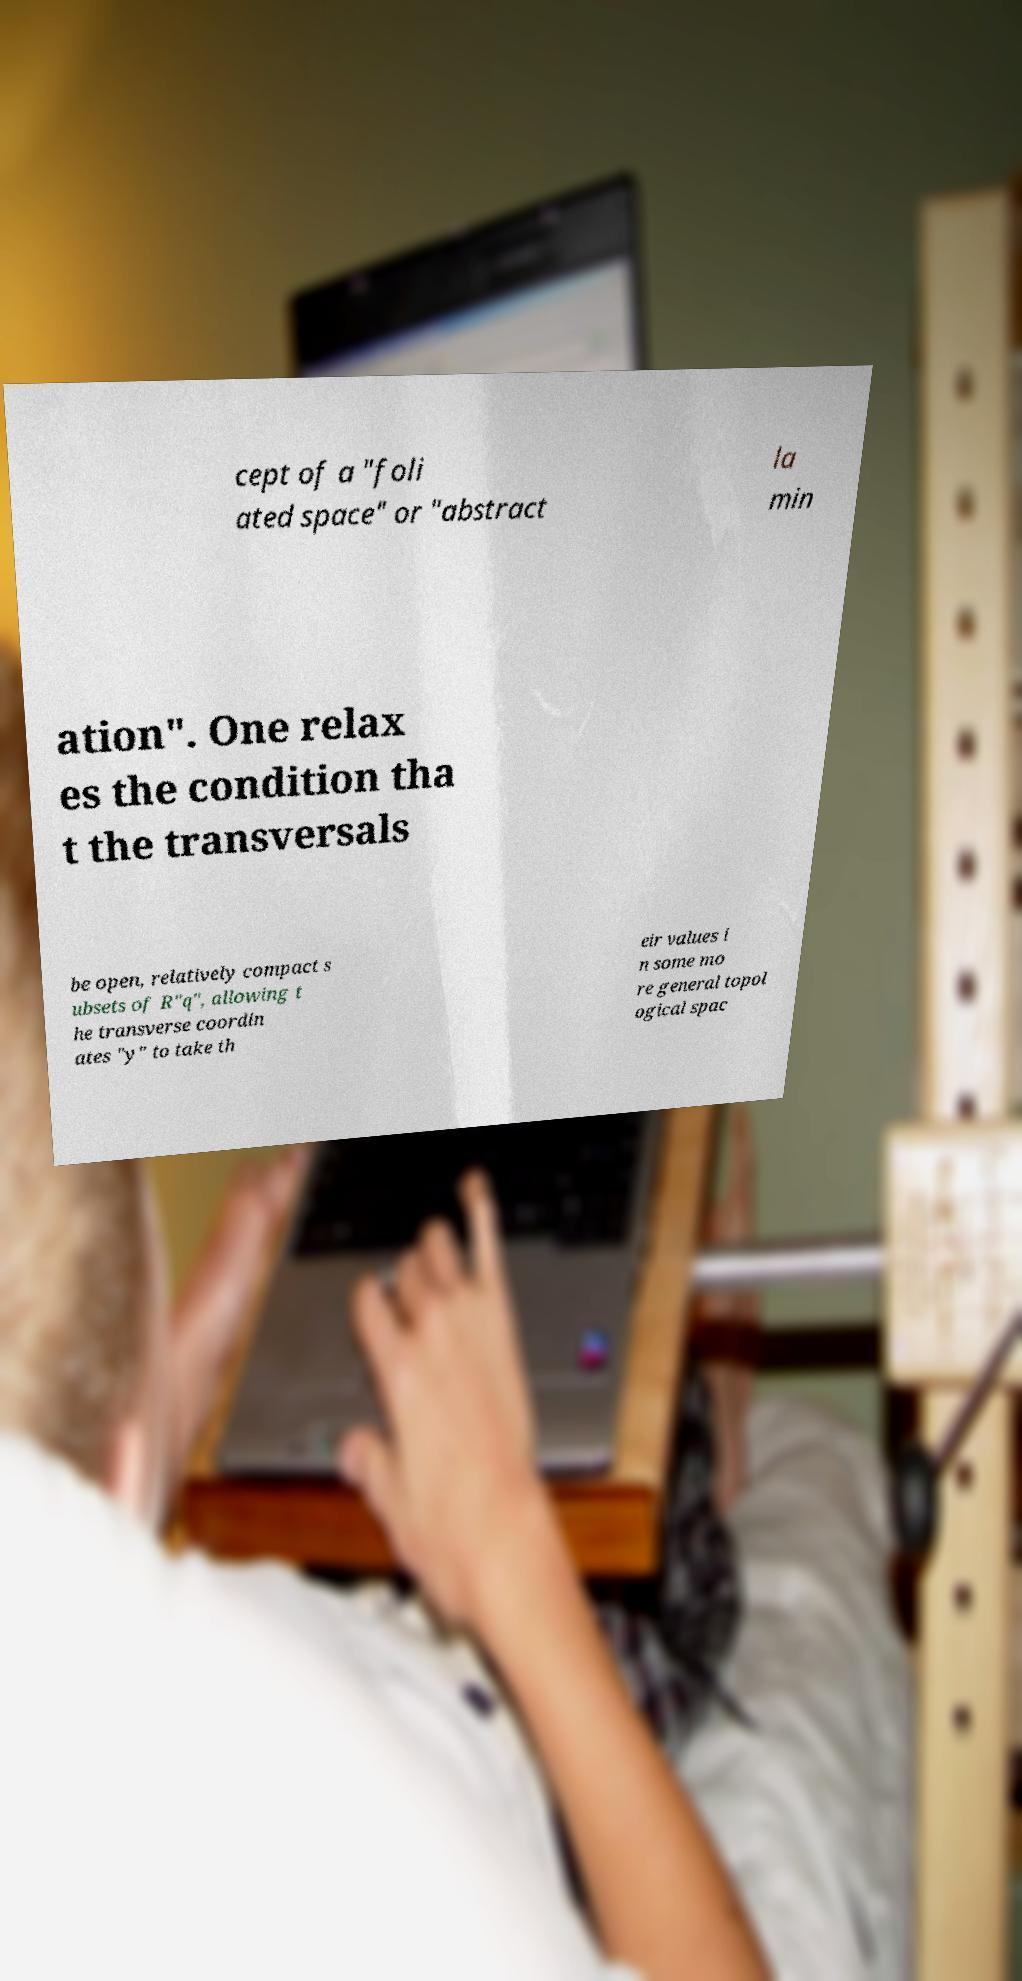Could you assist in decoding the text presented in this image and type it out clearly? cept of a "foli ated space" or "abstract la min ation". One relax es the condition tha t the transversals be open, relatively compact s ubsets of R"q", allowing t he transverse coordin ates "y" to take th eir values i n some mo re general topol ogical spac 